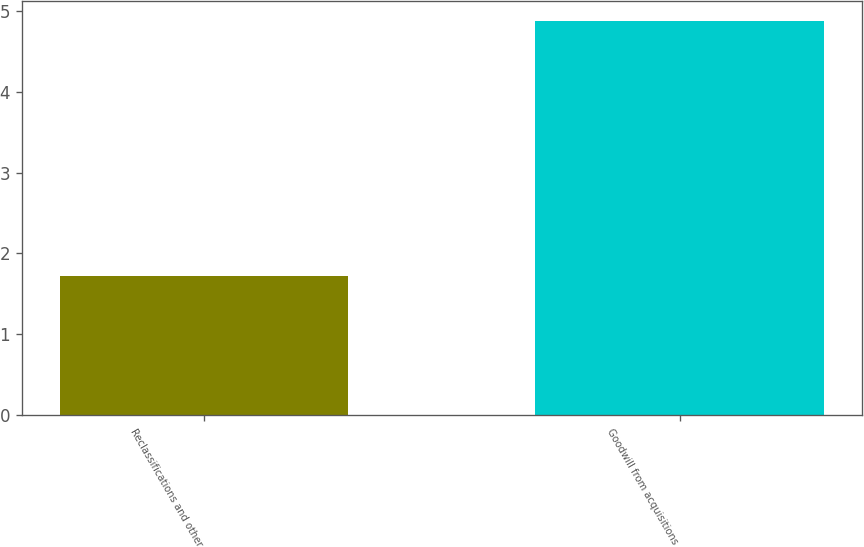Convert chart. <chart><loc_0><loc_0><loc_500><loc_500><bar_chart><fcel>Reclassifications and other<fcel>Goodwill from acquisitions<nl><fcel>1.72<fcel>4.88<nl></chart> 